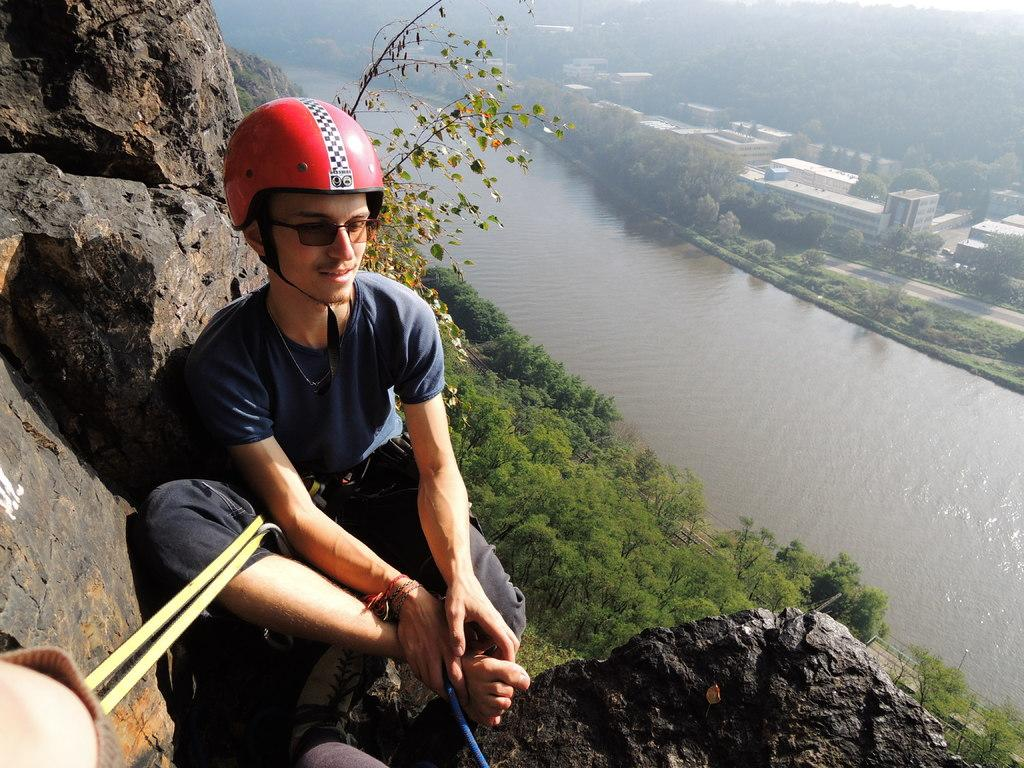Who is in the image? There is a man in the image. Where is the man located? The man is sitting on the top of a mountain. What is the man wearing? The man is wearing a helmet. What can be seen in the distance in the image? There is a river visible in the image. How long is the river? The river is long. What type of vegetation is near the river? Trees are present near the river. What other geographical features can be seen in the image? There are mountains visible in the image. What year is depicted in the image? The image does not depict a specific year; it is a photograph of a man sitting on a mountain. Can you see any squirrels in the image? There are no squirrels visible in the image. 